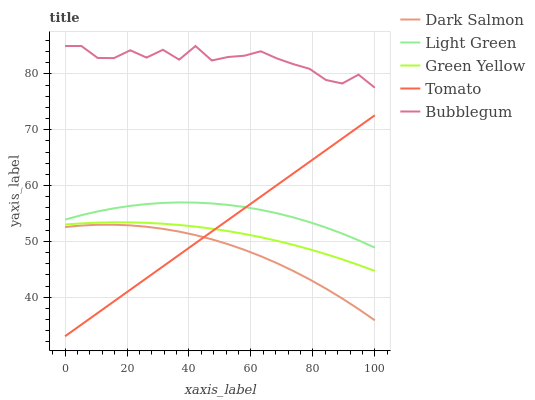Does Dark Salmon have the minimum area under the curve?
Answer yes or no. Yes. Does Bubblegum have the maximum area under the curve?
Answer yes or no. Yes. Does Green Yellow have the minimum area under the curve?
Answer yes or no. No. Does Green Yellow have the maximum area under the curve?
Answer yes or no. No. Is Tomato the smoothest?
Answer yes or no. Yes. Is Bubblegum the roughest?
Answer yes or no. Yes. Is Green Yellow the smoothest?
Answer yes or no. No. Is Green Yellow the roughest?
Answer yes or no. No. Does Tomato have the lowest value?
Answer yes or no. Yes. Does Green Yellow have the lowest value?
Answer yes or no. No. Does Bubblegum have the highest value?
Answer yes or no. Yes. Does Green Yellow have the highest value?
Answer yes or no. No. Is Dark Salmon less than Light Green?
Answer yes or no. Yes. Is Light Green greater than Green Yellow?
Answer yes or no. Yes. Does Tomato intersect Dark Salmon?
Answer yes or no. Yes. Is Tomato less than Dark Salmon?
Answer yes or no. No. Is Tomato greater than Dark Salmon?
Answer yes or no. No. Does Dark Salmon intersect Light Green?
Answer yes or no. No. 